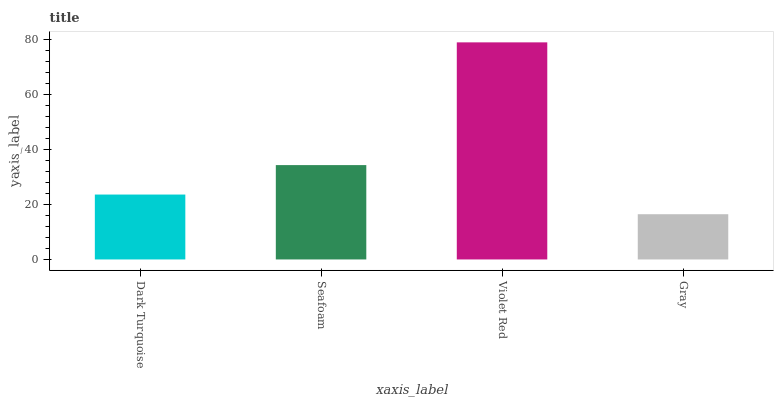Is Gray the minimum?
Answer yes or no. Yes. Is Violet Red the maximum?
Answer yes or no. Yes. Is Seafoam the minimum?
Answer yes or no. No. Is Seafoam the maximum?
Answer yes or no. No. Is Seafoam greater than Dark Turquoise?
Answer yes or no. Yes. Is Dark Turquoise less than Seafoam?
Answer yes or no. Yes. Is Dark Turquoise greater than Seafoam?
Answer yes or no. No. Is Seafoam less than Dark Turquoise?
Answer yes or no. No. Is Seafoam the high median?
Answer yes or no. Yes. Is Dark Turquoise the low median?
Answer yes or no. Yes. Is Violet Red the high median?
Answer yes or no. No. Is Seafoam the low median?
Answer yes or no. No. 